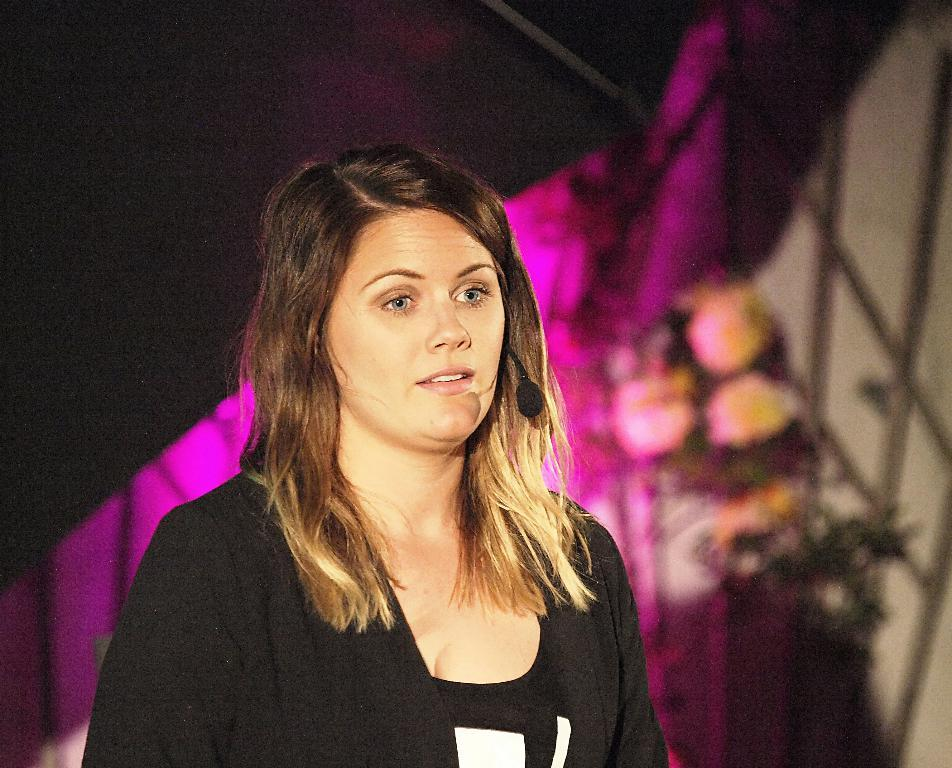Who is the main subject in the image? There is a woman in the image. What is the woman wearing? The woman is wearing a black dress. In which direction is the woman looking? The woman is looking to the right. What object is near the woman's ear? There is a microphone near the woman's ear. What can be seen in the background of the image? There is a wall and a flower plant in the background of the image. How does the woman grip the jelly in the image? There is no jelly present in the image, so the woman cannot grip any jelly. 